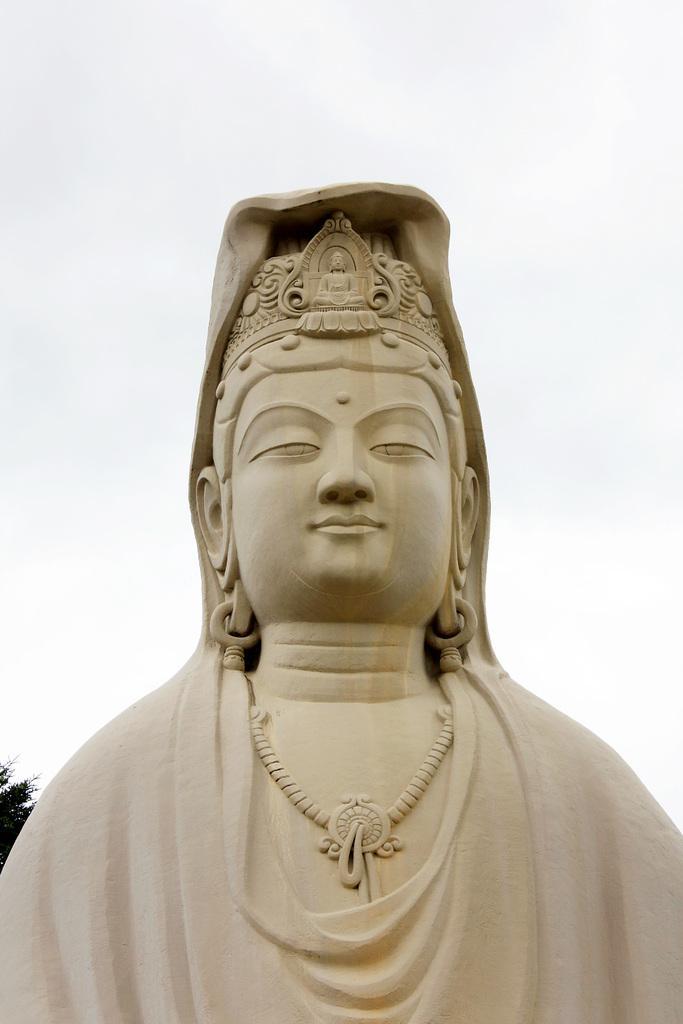Can you describe this image briefly? In the picture we can see an idol of goddess with some architect to it and which is cream in color and behind the idol we can see some part of tree and a sky. 